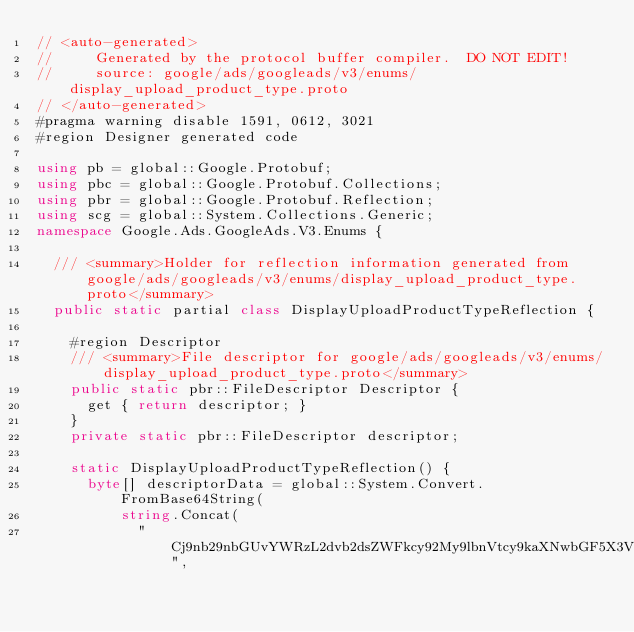Convert code to text. <code><loc_0><loc_0><loc_500><loc_500><_C#_>// <auto-generated>
//     Generated by the protocol buffer compiler.  DO NOT EDIT!
//     source: google/ads/googleads/v3/enums/display_upload_product_type.proto
// </auto-generated>
#pragma warning disable 1591, 0612, 3021
#region Designer generated code

using pb = global::Google.Protobuf;
using pbc = global::Google.Protobuf.Collections;
using pbr = global::Google.Protobuf.Reflection;
using scg = global::System.Collections.Generic;
namespace Google.Ads.GoogleAds.V3.Enums {

  /// <summary>Holder for reflection information generated from google/ads/googleads/v3/enums/display_upload_product_type.proto</summary>
  public static partial class DisplayUploadProductTypeReflection {

    #region Descriptor
    /// <summary>File descriptor for google/ads/googleads/v3/enums/display_upload_product_type.proto</summary>
    public static pbr::FileDescriptor Descriptor {
      get { return descriptor; }
    }
    private static pbr::FileDescriptor descriptor;

    static DisplayUploadProductTypeReflection() {
      byte[] descriptorData = global::System.Convert.FromBase64String(
          string.Concat(
            "Cj9nb29nbGUvYWRzL2dvb2dsZWFkcy92My9lbnVtcy9kaXNwbGF5X3VwbG9h",</code> 